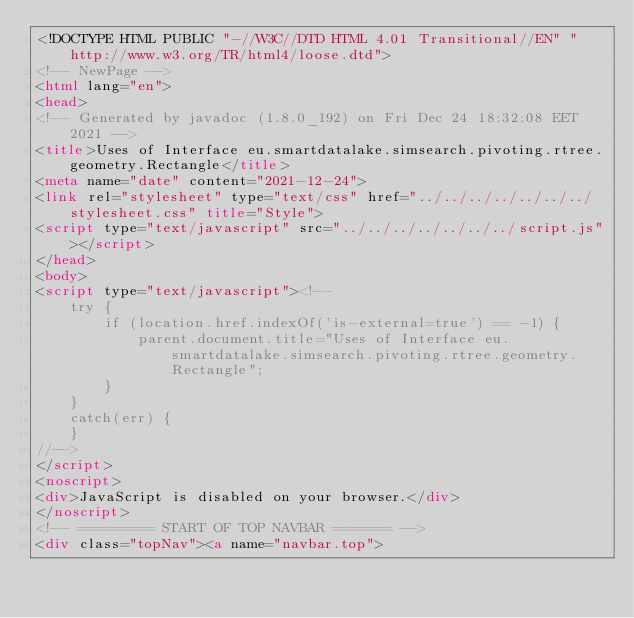<code> <loc_0><loc_0><loc_500><loc_500><_HTML_><!DOCTYPE HTML PUBLIC "-//W3C//DTD HTML 4.01 Transitional//EN" "http://www.w3.org/TR/html4/loose.dtd">
<!-- NewPage -->
<html lang="en">
<head>
<!-- Generated by javadoc (1.8.0_192) on Fri Dec 24 18:32:08 EET 2021 -->
<title>Uses of Interface eu.smartdatalake.simsearch.pivoting.rtree.geometry.Rectangle</title>
<meta name="date" content="2021-12-24">
<link rel="stylesheet" type="text/css" href="../../../../../../../stylesheet.css" title="Style">
<script type="text/javascript" src="../../../../../../../script.js"></script>
</head>
<body>
<script type="text/javascript"><!--
    try {
        if (location.href.indexOf('is-external=true') == -1) {
            parent.document.title="Uses of Interface eu.smartdatalake.simsearch.pivoting.rtree.geometry.Rectangle";
        }
    }
    catch(err) {
    }
//-->
</script>
<noscript>
<div>JavaScript is disabled on your browser.</div>
</noscript>
<!-- ========= START OF TOP NAVBAR ======= -->
<div class="topNav"><a name="navbar.top"></code> 